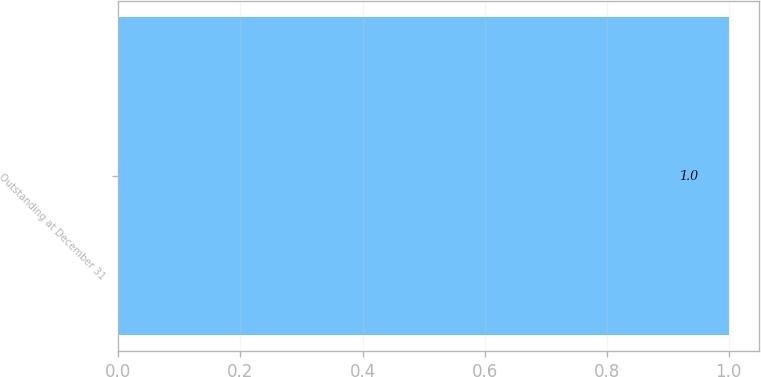Convert chart to OTSL. <chart><loc_0><loc_0><loc_500><loc_500><bar_chart><fcel>Outstanding at December 31<nl><fcel>1<nl></chart> 